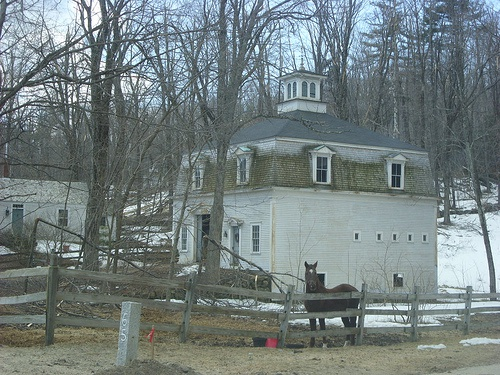Describe the objects in this image and their specific colors. I can see a horse in lightblue, gray, black, and darkgray tones in this image. 